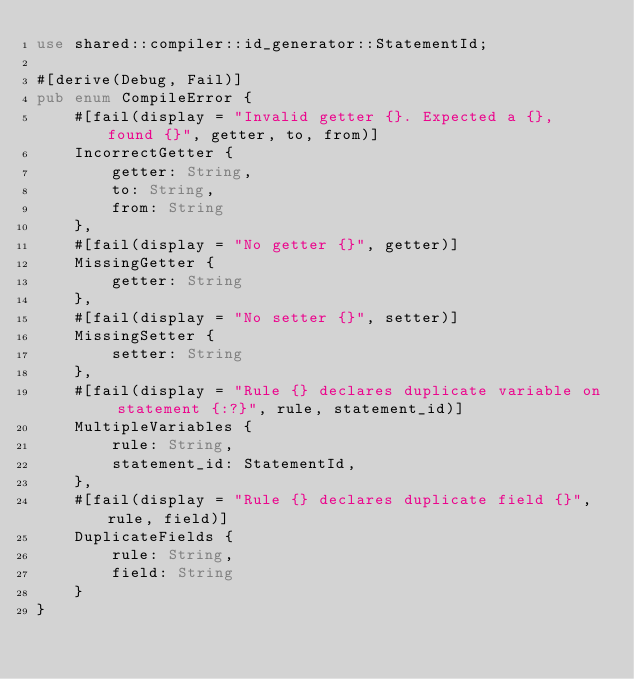Convert code to text. <code><loc_0><loc_0><loc_500><loc_500><_Rust_>use shared::compiler::id_generator::StatementId;

#[derive(Debug, Fail)]
pub enum CompileError {
    #[fail(display = "Invalid getter {}. Expected a {}, found {}", getter, to, from)]
    IncorrectGetter {
        getter: String,
        to: String,
        from: String
    },
    #[fail(display = "No getter {}", getter)]
    MissingGetter {
        getter: String
    },
    #[fail(display = "No setter {}", setter)]
    MissingSetter {
        setter: String
    },
    #[fail(display = "Rule {} declares duplicate variable on statement {:?}", rule, statement_id)]
    MultipleVariables {
        rule: String,
        statement_id: StatementId,
    },
    #[fail(display = "Rule {} declares duplicate field {}", rule, field)]
    DuplicateFields {
        rule: String,
        field: String
    }
}</code> 